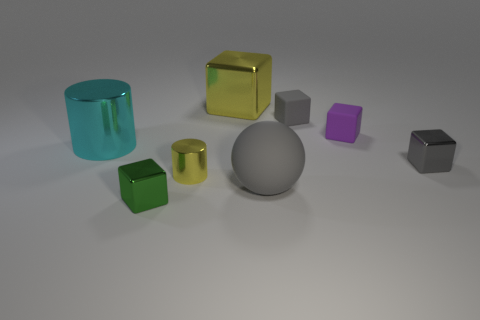Add 1 small yellow shiny things. How many objects exist? 9 Subtract all yellow blocks. How many blocks are left? 4 Subtract all green spheres. How many gray blocks are left? 2 Subtract 1 cubes. How many cubes are left? 4 Subtract all yellow blocks. How many blocks are left? 4 Subtract all cylinders. How many objects are left? 6 Subtract all red cubes. Subtract all yellow cylinders. How many cubes are left? 5 Subtract all small brown matte cubes. Subtract all tiny purple rubber things. How many objects are left? 7 Add 7 large yellow shiny blocks. How many large yellow shiny blocks are left? 8 Add 7 cyan rubber spheres. How many cyan rubber spheres exist? 7 